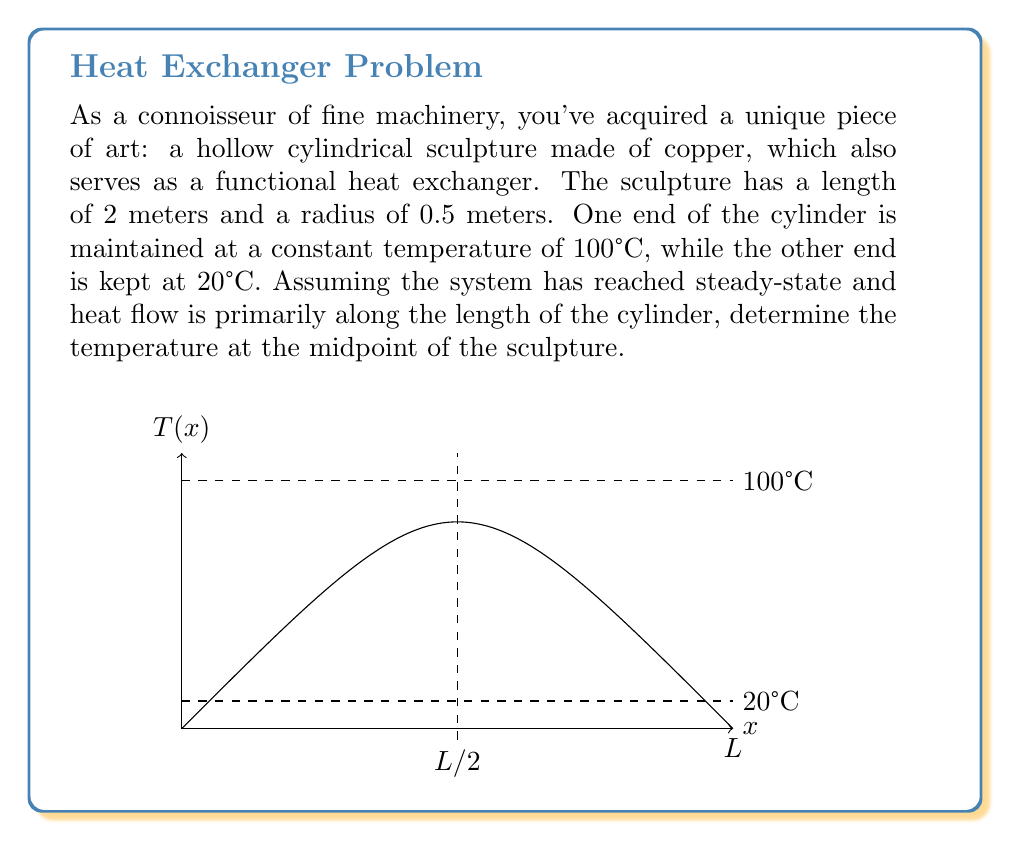Help me with this question. To solve this problem, we'll use the steady-state heat equation in one dimension. The steps are as follows:

1) The steady-state heat equation in one dimension is:

   $$\frac{d^2T}{dx^2} = 0$$

2) The general solution to this equation is:

   $$T(x) = Ax + B$$

   where A and B are constants to be determined from the boundary conditions.

3) We have the following boundary conditions:
   - At x = 0, T = 100°C
   - At x = L (where L = 2 meters), T = 20°C

4) Applying these boundary conditions:
   - At x = 0: 100 = B
   - At x = L: 20 = AL + B = AL + 100

5) From the second condition:
   $$AL = -80$$
   $$A = -\frac{80}{L} = -\frac{80}{2} = -40$$

6) So our temperature distribution is:

   $$T(x) = -40x + 100$$

7) To find the temperature at the midpoint, we substitute x = L/2 = 1:

   $$T(1) = -40(1) + 100 = 60$$

Therefore, the temperature at the midpoint of the sculpture is 60°C.
Answer: 60°C 